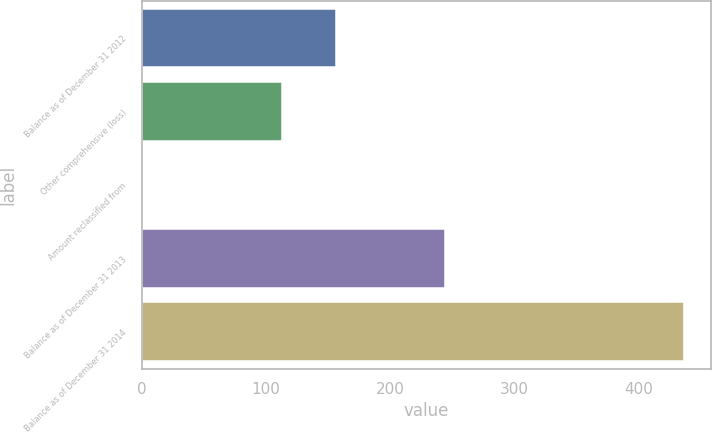<chart> <loc_0><loc_0><loc_500><loc_500><bar_chart><fcel>Balance as of December 31 2012<fcel>Other comprehensive (loss)<fcel>Amount reclassified from<fcel>Balance as of December 31 2013<fcel>Balance as of December 31 2014<nl><fcel>156.57<fcel>113<fcel>0.6<fcel>243.7<fcel>436.3<nl></chart> 